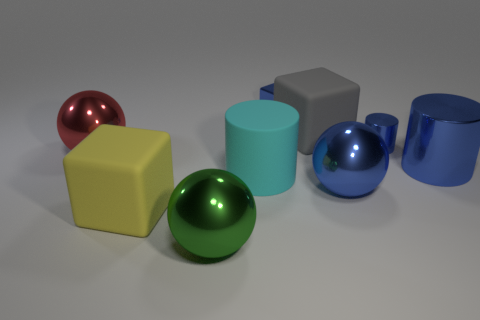Add 1 small green things. How many objects exist? 10 Subtract all cylinders. How many objects are left? 6 Subtract 0 yellow balls. How many objects are left? 9 Subtract all small things. Subtract all big blue cylinders. How many objects are left? 6 Add 1 large green balls. How many large green balls are left? 2 Add 9 blue metal blocks. How many blue metal blocks exist? 10 